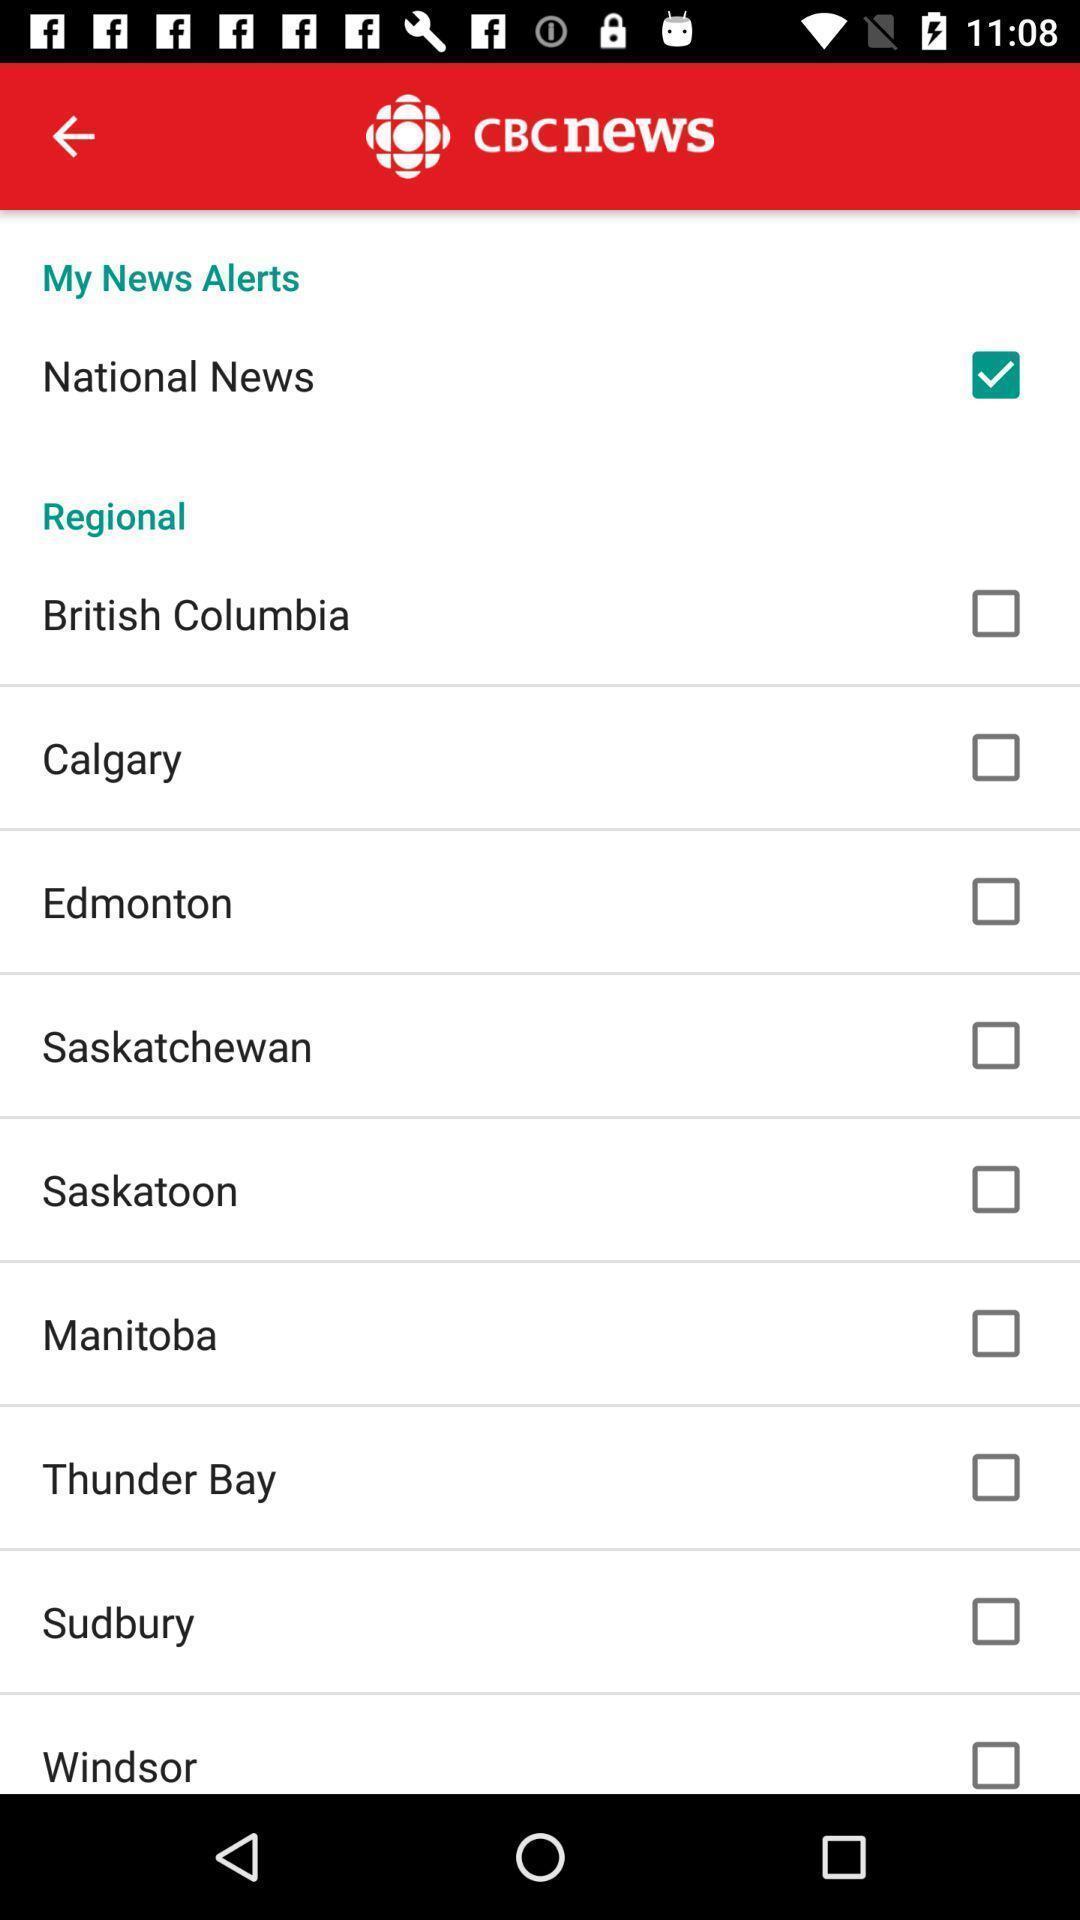Give me a summary of this screen capture. Page of a news application. 